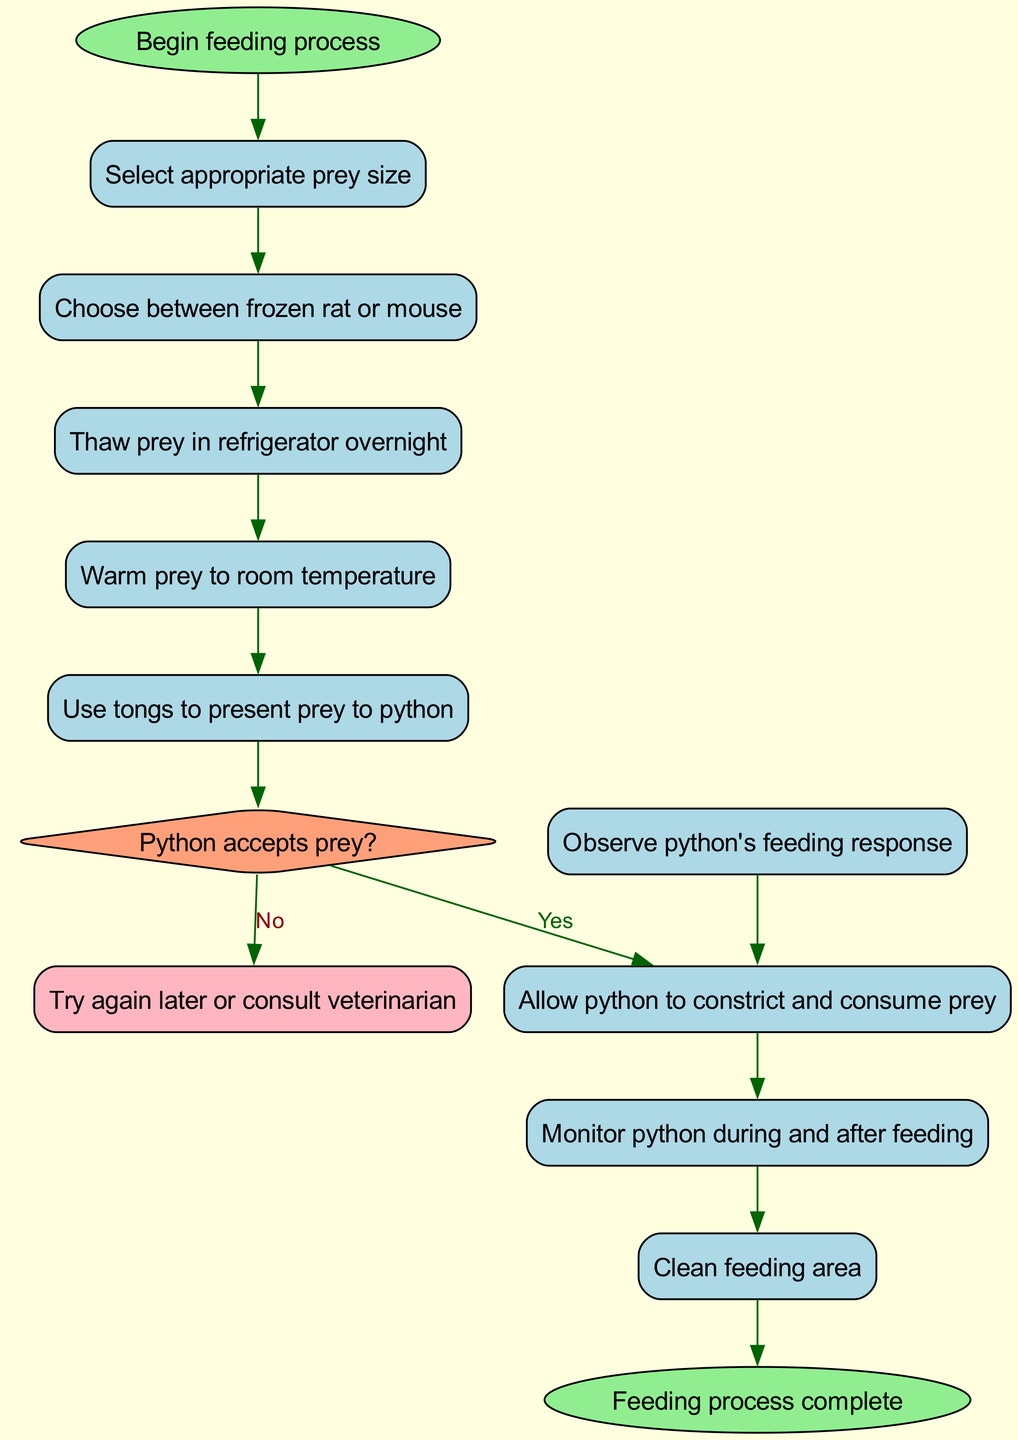What is the first activity in the feeding process? The first activity listed in the diagram is "Select appropriate prey size," which follows directly from the start node.
Answer: Select appropriate prey size What shape is used for decision nodes in the diagram? Decision nodes are represented using a diamond shape, as indicated by the visual representation in the diagram.
Answer: Diamond How many activities are included in the feeding process? There are a total of nine activities listed in the diagram, from "Select appropriate prey size" to "Clean feeding area."
Answer: Nine What happens if the python does not accept the prey? If the python does not accept the prey, the diagram indicates the direction to "Try again later or consult veterinarian."
Answer: Try again later or consult veterinarian What is the last activity before cleaning the feeding area? The last activity before cleaning the feeding area is "Monitor python during and after feeding," which is directly connected to the cleaning process.
Answer: Monitor python during and after feeding What is the decision question posed during the feeding process? The decision question asked in the diagram is "Python accepts prey?" which leads to different outcomes based on the response.
Answer: Python accepts prey? How many edges connect the start node to activities? The start node is connected to the first activity, and subsequently, each activity has a directed edge to the next activity, resulting in a total of eight edges connecting the start node to the activities.
Answer: Eight What activity follows "Warm prey to room temperature"? Following "Warm prey to room temperature," the next activity is "Use tongs to present prey to python," as shown by the direct flow in the diagram.
Answer: Use tongs to present prey to python What color represents the end node in the diagram? The end node is represented in light green as indicated by the diagram's color coding.
Answer: Light green 